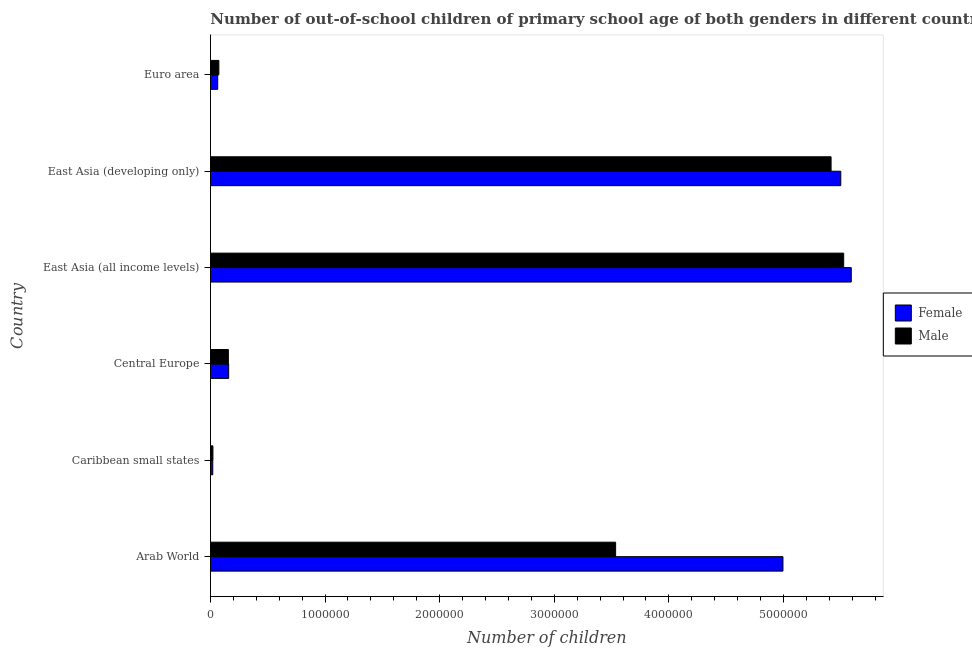How many groups of bars are there?
Your answer should be compact. 6. Are the number of bars on each tick of the Y-axis equal?
Offer a terse response. Yes. How many bars are there on the 6th tick from the top?
Keep it short and to the point. 2. How many bars are there on the 1st tick from the bottom?
Your answer should be very brief. 2. What is the label of the 3rd group of bars from the top?
Give a very brief answer. East Asia (all income levels). What is the number of male out-of-school students in Euro area?
Your answer should be very brief. 7.33e+04. Across all countries, what is the maximum number of female out-of-school students?
Your answer should be compact. 5.59e+06. Across all countries, what is the minimum number of male out-of-school students?
Your answer should be very brief. 2.14e+04. In which country was the number of female out-of-school students maximum?
Give a very brief answer. East Asia (all income levels). In which country was the number of male out-of-school students minimum?
Your answer should be very brief. Caribbean small states. What is the total number of female out-of-school students in the graph?
Your answer should be compact. 1.63e+07. What is the difference between the number of female out-of-school students in Arab World and that in Euro area?
Provide a short and direct response. 4.93e+06. What is the difference between the number of female out-of-school students in East Asia (all income levels) and the number of male out-of-school students in Arab World?
Ensure brevity in your answer.  2.06e+06. What is the average number of male out-of-school students per country?
Offer a terse response. 2.45e+06. What is the difference between the number of male out-of-school students and number of female out-of-school students in Arab World?
Provide a short and direct response. -1.46e+06. In how many countries, is the number of female out-of-school students greater than 5400000 ?
Keep it short and to the point. 2. What is the ratio of the number of male out-of-school students in Caribbean small states to that in Euro area?
Make the answer very short. 0.29. Is the number of male out-of-school students in Central Europe less than that in East Asia (all income levels)?
Your answer should be very brief. Yes. What is the difference between the highest and the second highest number of male out-of-school students?
Offer a very short reply. 1.10e+05. What is the difference between the highest and the lowest number of female out-of-school students?
Offer a very short reply. 5.57e+06. Is the sum of the number of female out-of-school students in Arab World and Euro area greater than the maximum number of male out-of-school students across all countries?
Keep it short and to the point. No. What does the 2nd bar from the top in East Asia (all income levels) represents?
Give a very brief answer. Female. Are all the bars in the graph horizontal?
Your response must be concise. Yes. How many countries are there in the graph?
Make the answer very short. 6. What is the difference between two consecutive major ticks on the X-axis?
Provide a short and direct response. 1.00e+06. Are the values on the major ticks of X-axis written in scientific E-notation?
Provide a short and direct response. No. Where does the legend appear in the graph?
Provide a succinct answer. Center right. What is the title of the graph?
Offer a very short reply. Number of out-of-school children of primary school age of both genders in different countries. What is the label or title of the X-axis?
Your response must be concise. Number of children. What is the label or title of the Y-axis?
Provide a short and direct response. Country. What is the Number of children in Female in Arab World?
Offer a terse response. 5.00e+06. What is the Number of children of Male in Arab World?
Provide a succinct answer. 3.54e+06. What is the Number of children in Female in Caribbean small states?
Give a very brief answer. 2.00e+04. What is the Number of children of Male in Caribbean small states?
Give a very brief answer. 2.14e+04. What is the Number of children of Female in Central Europe?
Keep it short and to the point. 1.59e+05. What is the Number of children in Male in Central Europe?
Offer a very short reply. 1.56e+05. What is the Number of children of Female in East Asia (all income levels)?
Provide a short and direct response. 5.59e+06. What is the Number of children in Male in East Asia (all income levels)?
Your answer should be compact. 5.53e+06. What is the Number of children in Female in East Asia (developing only)?
Provide a succinct answer. 5.50e+06. What is the Number of children of Male in East Asia (developing only)?
Provide a succinct answer. 5.42e+06. What is the Number of children of Female in Euro area?
Your response must be concise. 6.33e+04. What is the Number of children in Male in Euro area?
Keep it short and to the point. 7.33e+04. Across all countries, what is the maximum Number of children of Female?
Offer a very short reply. 5.59e+06. Across all countries, what is the maximum Number of children of Male?
Your answer should be compact. 5.53e+06. Across all countries, what is the minimum Number of children of Female?
Provide a succinct answer. 2.00e+04. Across all countries, what is the minimum Number of children of Male?
Give a very brief answer. 2.14e+04. What is the total Number of children in Female in the graph?
Ensure brevity in your answer.  1.63e+07. What is the total Number of children in Male in the graph?
Ensure brevity in your answer.  1.47e+07. What is the difference between the Number of children of Female in Arab World and that in Caribbean small states?
Provide a short and direct response. 4.98e+06. What is the difference between the Number of children of Male in Arab World and that in Caribbean small states?
Your answer should be very brief. 3.51e+06. What is the difference between the Number of children of Female in Arab World and that in Central Europe?
Offer a terse response. 4.84e+06. What is the difference between the Number of children of Male in Arab World and that in Central Europe?
Ensure brevity in your answer.  3.38e+06. What is the difference between the Number of children in Female in Arab World and that in East Asia (all income levels)?
Make the answer very short. -5.96e+05. What is the difference between the Number of children in Male in Arab World and that in East Asia (all income levels)?
Make the answer very short. -1.99e+06. What is the difference between the Number of children of Female in Arab World and that in East Asia (developing only)?
Offer a terse response. -5.05e+05. What is the difference between the Number of children of Male in Arab World and that in East Asia (developing only)?
Your answer should be compact. -1.88e+06. What is the difference between the Number of children of Female in Arab World and that in Euro area?
Provide a succinct answer. 4.93e+06. What is the difference between the Number of children of Male in Arab World and that in Euro area?
Provide a succinct answer. 3.46e+06. What is the difference between the Number of children in Female in Caribbean small states and that in Central Europe?
Provide a succinct answer. -1.39e+05. What is the difference between the Number of children in Male in Caribbean small states and that in Central Europe?
Give a very brief answer. -1.35e+05. What is the difference between the Number of children in Female in Caribbean small states and that in East Asia (all income levels)?
Provide a short and direct response. -5.57e+06. What is the difference between the Number of children of Male in Caribbean small states and that in East Asia (all income levels)?
Ensure brevity in your answer.  -5.50e+06. What is the difference between the Number of children in Female in Caribbean small states and that in East Asia (developing only)?
Make the answer very short. -5.48e+06. What is the difference between the Number of children in Male in Caribbean small states and that in East Asia (developing only)?
Provide a short and direct response. -5.39e+06. What is the difference between the Number of children of Female in Caribbean small states and that in Euro area?
Keep it short and to the point. -4.33e+04. What is the difference between the Number of children in Male in Caribbean small states and that in Euro area?
Provide a succinct answer. -5.18e+04. What is the difference between the Number of children of Female in Central Europe and that in East Asia (all income levels)?
Your answer should be compact. -5.43e+06. What is the difference between the Number of children of Male in Central Europe and that in East Asia (all income levels)?
Offer a terse response. -5.37e+06. What is the difference between the Number of children in Female in Central Europe and that in East Asia (developing only)?
Provide a short and direct response. -5.34e+06. What is the difference between the Number of children in Male in Central Europe and that in East Asia (developing only)?
Give a very brief answer. -5.26e+06. What is the difference between the Number of children in Female in Central Europe and that in Euro area?
Your answer should be compact. 9.56e+04. What is the difference between the Number of children in Male in Central Europe and that in Euro area?
Make the answer very short. 8.30e+04. What is the difference between the Number of children in Female in East Asia (all income levels) and that in East Asia (developing only)?
Your answer should be compact. 9.15e+04. What is the difference between the Number of children in Male in East Asia (all income levels) and that in East Asia (developing only)?
Your response must be concise. 1.10e+05. What is the difference between the Number of children of Female in East Asia (all income levels) and that in Euro area?
Your response must be concise. 5.53e+06. What is the difference between the Number of children of Male in East Asia (all income levels) and that in Euro area?
Make the answer very short. 5.45e+06. What is the difference between the Number of children of Female in East Asia (developing only) and that in Euro area?
Make the answer very short. 5.44e+06. What is the difference between the Number of children of Male in East Asia (developing only) and that in Euro area?
Your answer should be very brief. 5.34e+06. What is the difference between the Number of children in Female in Arab World and the Number of children in Male in Caribbean small states?
Offer a very short reply. 4.97e+06. What is the difference between the Number of children of Female in Arab World and the Number of children of Male in Central Europe?
Keep it short and to the point. 4.84e+06. What is the difference between the Number of children in Female in Arab World and the Number of children in Male in East Asia (all income levels)?
Your answer should be compact. -5.30e+05. What is the difference between the Number of children in Female in Arab World and the Number of children in Male in East Asia (developing only)?
Your answer should be compact. -4.20e+05. What is the difference between the Number of children of Female in Arab World and the Number of children of Male in Euro area?
Make the answer very short. 4.92e+06. What is the difference between the Number of children in Female in Caribbean small states and the Number of children in Male in Central Europe?
Provide a short and direct response. -1.36e+05. What is the difference between the Number of children in Female in Caribbean small states and the Number of children in Male in East Asia (all income levels)?
Make the answer very short. -5.51e+06. What is the difference between the Number of children in Female in Caribbean small states and the Number of children in Male in East Asia (developing only)?
Provide a succinct answer. -5.40e+06. What is the difference between the Number of children of Female in Caribbean small states and the Number of children of Male in Euro area?
Offer a very short reply. -5.32e+04. What is the difference between the Number of children in Female in Central Europe and the Number of children in Male in East Asia (all income levels)?
Your response must be concise. -5.37e+06. What is the difference between the Number of children in Female in Central Europe and the Number of children in Male in East Asia (developing only)?
Your answer should be compact. -5.26e+06. What is the difference between the Number of children of Female in Central Europe and the Number of children of Male in Euro area?
Ensure brevity in your answer.  8.56e+04. What is the difference between the Number of children of Female in East Asia (all income levels) and the Number of children of Male in East Asia (developing only)?
Offer a terse response. 1.76e+05. What is the difference between the Number of children of Female in East Asia (all income levels) and the Number of children of Male in Euro area?
Ensure brevity in your answer.  5.52e+06. What is the difference between the Number of children of Female in East Asia (developing only) and the Number of children of Male in Euro area?
Provide a succinct answer. 5.43e+06. What is the average Number of children of Female per country?
Your response must be concise. 2.72e+06. What is the average Number of children of Male per country?
Offer a very short reply. 2.45e+06. What is the difference between the Number of children in Female and Number of children in Male in Arab World?
Ensure brevity in your answer.  1.46e+06. What is the difference between the Number of children of Female and Number of children of Male in Caribbean small states?
Give a very brief answer. -1408. What is the difference between the Number of children in Female and Number of children in Male in Central Europe?
Provide a succinct answer. 2661. What is the difference between the Number of children of Female and Number of children of Male in East Asia (all income levels)?
Keep it short and to the point. 6.62e+04. What is the difference between the Number of children in Female and Number of children in Male in East Asia (developing only)?
Provide a succinct answer. 8.46e+04. What is the difference between the Number of children of Female and Number of children of Male in Euro area?
Give a very brief answer. -9955. What is the ratio of the Number of children of Female in Arab World to that in Caribbean small states?
Make the answer very short. 249.39. What is the ratio of the Number of children of Male in Arab World to that in Caribbean small states?
Your response must be concise. 164.91. What is the ratio of the Number of children of Female in Arab World to that in Central Europe?
Provide a succinct answer. 31.44. What is the ratio of the Number of children in Male in Arab World to that in Central Europe?
Offer a very short reply. 22.63. What is the ratio of the Number of children of Female in Arab World to that in East Asia (all income levels)?
Provide a succinct answer. 0.89. What is the ratio of the Number of children in Male in Arab World to that in East Asia (all income levels)?
Your answer should be very brief. 0.64. What is the ratio of the Number of children in Female in Arab World to that in East Asia (developing only)?
Provide a short and direct response. 0.91. What is the ratio of the Number of children of Male in Arab World to that in East Asia (developing only)?
Your answer should be compact. 0.65. What is the ratio of the Number of children in Female in Arab World to that in Euro area?
Provide a short and direct response. 78.93. What is the ratio of the Number of children in Male in Arab World to that in Euro area?
Ensure brevity in your answer.  48.27. What is the ratio of the Number of children of Female in Caribbean small states to that in Central Europe?
Provide a short and direct response. 0.13. What is the ratio of the Number of children of Male in Caribbean small states to that in Central Europe?
Your answer should be very brief. 0.14. What is the ratio of the Number of children in Female in Caribbean small states to that in East Asia (all income levels)?
Ensure brevity in your answer.  0. What is the ratio of the Number of children in Male in Caribbean small states to that in East Asia (all income levels)?
Give a very brief answer. 0. What is the ratio of the Number of children in Female in Caribbean small states to that in East Asia (developing only)?
Ensure brevity in your answer.  0. What is the ratio of the Number of children in Male in Caribbean small states to that in East Asia (developing only)?
Offer a very short reply. 0. What is the ratio of the Number of children of Female in Caribbean small states to that in Euro area?
Provide a short and direct response. 0.32. What is the ratio of the Number of children of Male in Caribbean small states to that in Euro area?
Ensure brevity in your answer.  0.29. What is the ratio of the Number of children of Female in Central Europe to that in East Asia (all income levels)?
Your response must be concise. 0.03. What is the ratio of the Number of children in Male in Central Europe to that in East Asia (all income levels)?
Ensure brevity in your answer.  0.03. What is the ratio of the Number of children of Female in Central Europe to that in East Asia (developing only)?
Provide a short and direct response. 0.03. What is the ratio of the Number of children of Male in Central Europe to that in East Asia (developing only)?
Provide a succinct answer. 0.03. What is the ratio of the Number of children in Female in Central Europe to that in Euro area?
Give a very brief answer. 2.51. What is the ratio of the Number of children in Male in Central Europe to that in Euro area?
Offer a terse response. 2.13. What is the ratio of the Number of children in Female in East Asia (all income levels) to that in East Asia (developing only)?
Provide a short and direct response. 1.02. What is the ratio of the Number of children in Male in East Asia (all income levels) to that in East Asia (developing only)?
Offer a very short reply. 1.02. What is the ratio of the Number of children in Female in East Asia (all income levels) to that in Euro area?
Provide a succinct answer. 88.34. What is the ratio of the Number of children of Male in East Asia (all income levels) to that in Euro area?
Provide a short and direct response. 75.43. What is the ratio of the Number of children of Female in East Asia (developing only) to that in Euro area?
Offer a very short reply. 86.9. What is the ratio of the Number of children of Male in East Asia (developing only) to that in Euro area?
Provide a short and direct response. 73.93. What is the difference between the highest and the second highest Number of children of Female?
Offer a very short reply. 9.15e+04. What is the difference between the highest and the second highest Number of children of Male?
Ensure brevity in your answer.  1.10e+05. What is the difference between the highest and the lowest Number of children in Female?
Offer a very short reply. 5.57e+06. What is the difference between the highest and the lowest Number of children of Male?
Your response must be concise. 5.50e+06. 